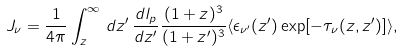Convert formula to latex. <formula><loc_0><loc_0><loc_500><loc_500>J _ { \nu } = \frac { 1 } { 4 \pi } \int _ { z } ^ { \infty } \, d z ^ { \prime } \, \frac { d l _ { p } } { d z ^ { \prime } } \frac { ( 1 + z ) ^ { 3 } } { ( 1 + z ^ { \prime } ) ^ { 3 } } \langle \epsilon _ { \nu ^ { \prime } } ( z ^ { \prime } ) \exp [ - \tau _ { \nu } ( z , z ^ { \prime } ) ] \rangle ,</formula> 